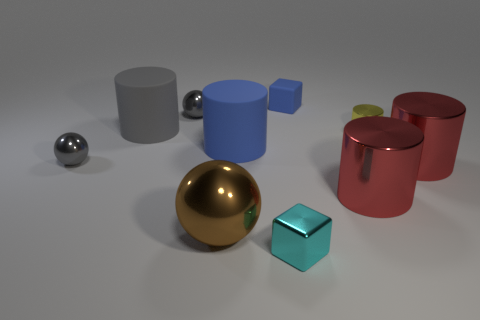What number of big brown shiny spheres are to the left of the small block in front of the blue matte thing that is to the right of the blue cylinder?
Your answer should be very brief. 1. The gray rubber object is what shape?
Provide a short and direct response. Cylinder. What number of other objects are there of the same material as the tiny cyan cube?
Your answer should be compact. 6. Do the blue block and the blue rubber cylinder have the same size?
Your answer should be compact. No. What is the shape of the big metal thing that is on the left side of the tiny rubber object?
Provide a short and direct response. Sphere. What color is the big rubber thing behind the small thing that is to the right of the tiny matte block?
Keep it short and to the point. Gray. There is a blue matte thing that is to the left of the matte block; is its shape the same as the rubber thing to the left of the brown metal thing?
Provide a short and direct response. Yes. There is a gray thing that is the same size as the blue matte cylinder; what is its shape?
Make the answer very short. Cylinder. What is the color of the big ball that is the same material as the tiny yellow cylinder?
Offer a very short reply. Brown. There is a tiny cyan metallic thing; does it have the same shape as the rubber thing to the right of the blue cylinder?
Offer a very short reply. Yes. 